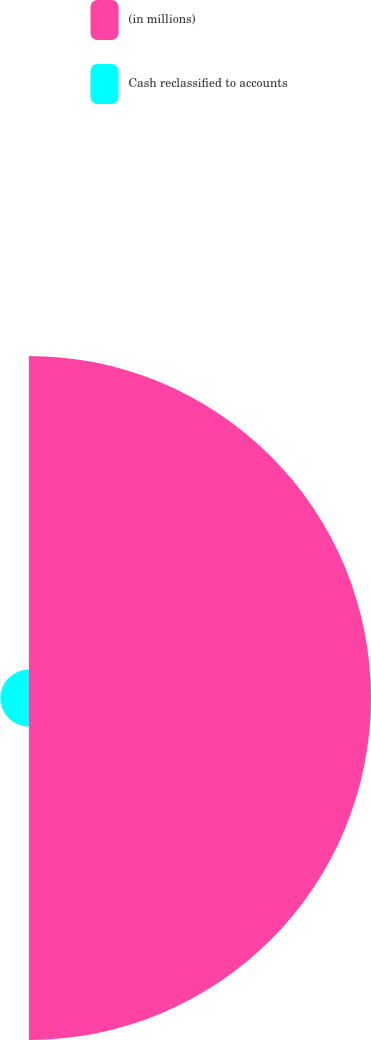Convert chart to OTSL. <chart><loc_0><loc_0><loc_500><loc_500><pie_chart><fcel>(in millions)<fcel>Cash reclassified to accounts<nl><fcel>92.3%<fcel>7.7%<nl></chart> 